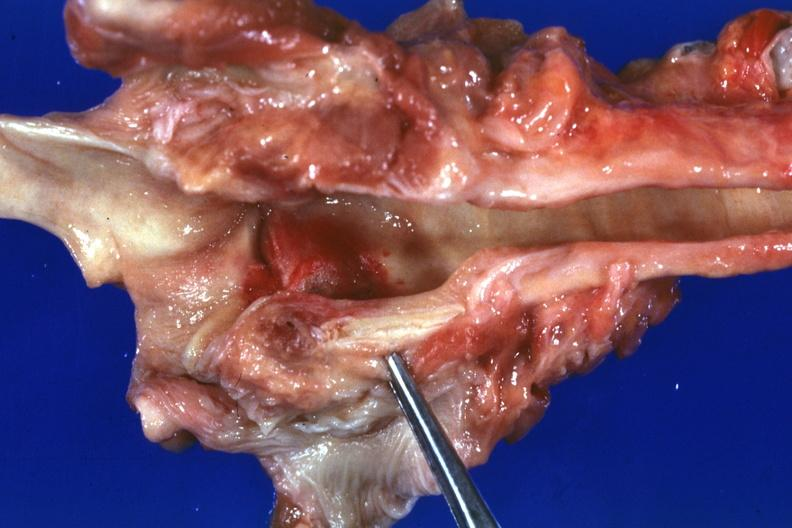what is present?
Answer the question using a single word or phrase. Larynx 